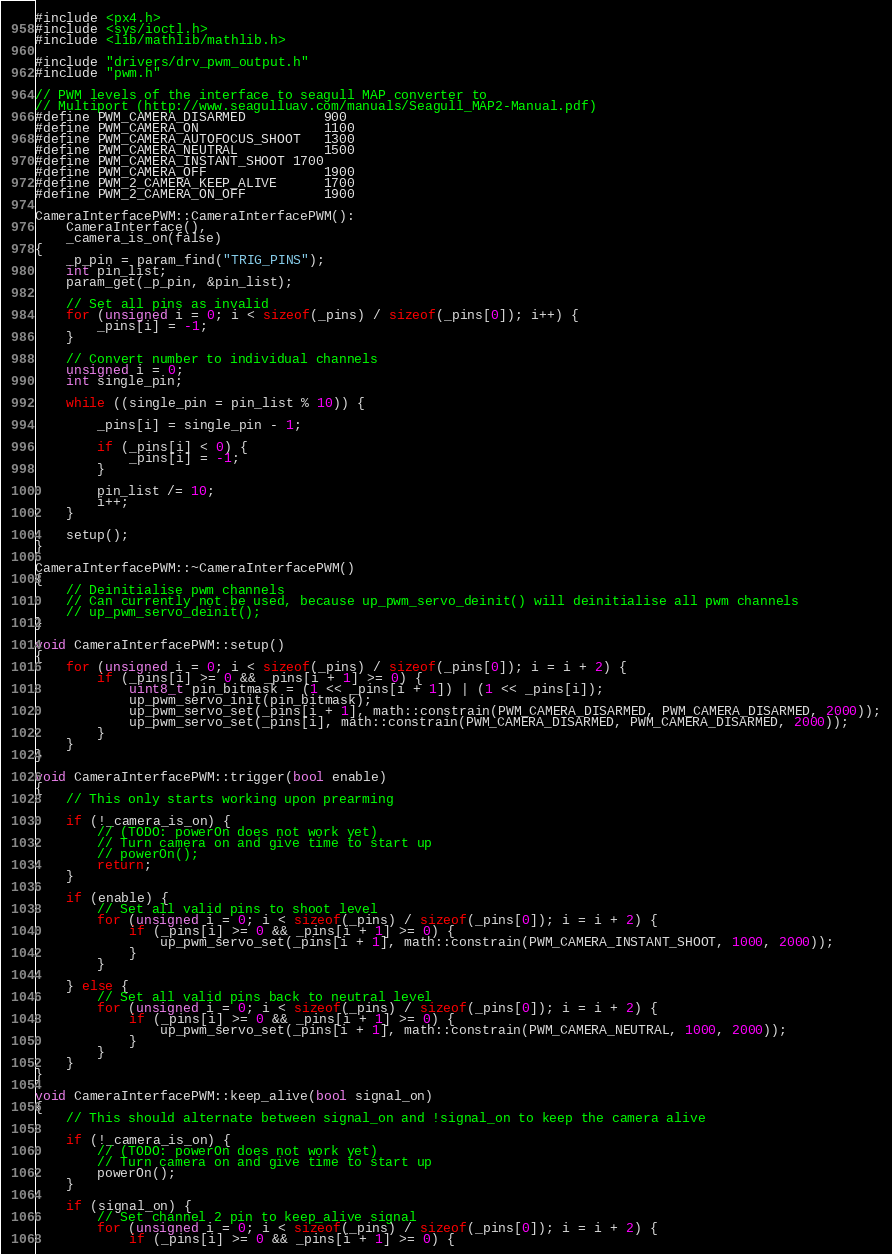Convert code to text. <code><loc_0><loc_0><loc_500><loc_500><_C++_>#include <px4.h>
#include <sys/ioctl.h>
#include <lib/mathlib/mathlib.h>

#include "drivers/drv_pwm_output.h"
#include "pwm.h"

// PWM levels of the interface to seagull MAP converter to
// Multiport (http://www.seagulluav.com/manuals/Seagull_MAP2-Manual.pdf)
#define PWM_CAMERA_DISARMED			900
#define PWM_CAMERA_ON				1100
#define PWM_CAMERA_AUTOFOCUS_SHOOT	1300
#define PWM_CAMERA_NEUTRAL			1500
#define PWM_CAMERA_INSTANT_SHOOT	1700
#define PWM_CAMERA_OFF				1900
#define PWM_2_CAMERA_KEEP_ALIVE		1700
#define PWM_2_CAMERA_ON_OFF			1900

CameraInterfacePWM::CameraInterfacePWM():
	CameraInterface(),
	_camera_is_on(false)
{
	_p_pin = param_find("TRIG_PINS");
	int pin_list;
	param_get(_p_pin, &pin_list);

	// Set all pins as invalid
	for (unsigned i = 0; i < sizeof(_pins) / sizeof(_pins[0]); i++) {
		_pins[i] = -1;
	}

	// Convert number to individual channels
	unsigned i = 0;
	int single_pin;

	while ((single_pin = pin_list % 10)) {

		_pins[i] = single_pin - 1;

		if (_pins[i] < 0) {
			_pins[i] = -1;
		}

		pin_list /= 10;
		i++;
	}

	setup();
}

CameraInterfacePWM::~CameraInterfacePWM()
{
	// Deinitialise pwm channels
	// Can currently not be used, because up_pwm_servo_deinit() will deinitialise all pwm channels
	// up_pwm_servo_deinit();
}

void CameraInterfacePWM::setup()
{
	for (unsigned i = 0; i < sizeof(_pins) / sizeof(_pins[0]); i = i + 2) {
		if (_pins[i] >= 0 && _pins[i + 1] >= 0) {
			uint8_t pin_bitmask = (1 << _pins[i + 1]) | (1 << _pins[i]);
			up_pwm_servo_init(pin_bitmask);
			up_pwm_servo_set(_pins[i + 1], math::constrain(PWM_CAMERA_DISARMED, PWM_CAMERA_DISARMED, 2000));
			up_pwm_servo_set(_pins[i], math::constrain(PWM_CAMERA_DISARMED, PWM_CAMERA_DISARMED, 2000));
		}
	}
}

void CameraInterfacePWM::trigger(bool enable)
{
	// This only starts working upon prearming

	if (!_camera_is_on) {
		// (TODO: powerOn does not work yet)
		// Turn camera on and give time to start up
		// powerOn();
		return;
	}

	if (enable) {
		// Set all valid pins to shoot level
		for (unsigned i = 0; i < sizeof(_pins) / sizeof(_pins[0]); i = i + 2) {
			if (_pins[i] >= 0 && _pins[i + 1] >= 0) {
				up_pwm_servo_set(_pins[i + 1], math::constrain(PWM_CAMERA_INSTANT_SHOOT, 1000, 2000));
			}
		}

	} else {
		// Set all valid pins back to neutral level
		for (unsigned i = 0; i < sizeof(_pins) / sizeof(_pins[0]); i = i + 2) {
			if (_pins[i] >= 0 && _pins[i + 1] >= 0) {
				up_pwm_servo_set(_pins[i + 1], math::constrain(PWM_CAMERA_NEUTRAL, 1000, 2000));
			}
		}
	}
}

void CameraInterfacePWM::keep_alive(bool signal_on)
{
	// This should alternate between signal_on and !signal_on to keep the camera alive

	if (!_camera_is_on) {
		// (TODO: powerOn does not work yet)
		// Turn camera on and give time to start up
		powerOn();
	}

	if (signal_on) {
		// Set channel 2 pin to keep_alive signal
		for (unsigned i = 0; i < sizeof(_pins) / sizeof(_pins[0]); i = i + 2) {
			if (_pins[i] >= 0 && _pins[i + 1] >= 0) {</code> 